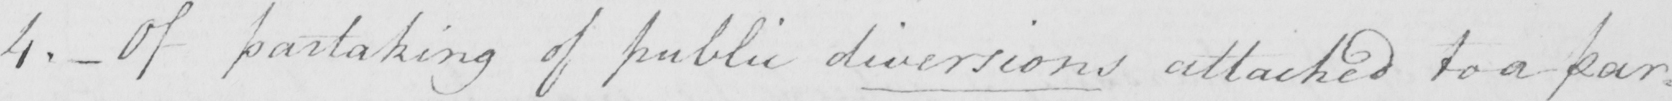What does this handwritten line say? 4 . _  Of partaking of public diversions attached to a par= 